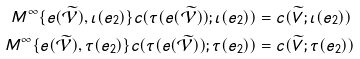<formula> <loc_0><loc_0><loc_500><loc_500>M ^ { \infty } \{ e ( \widetilde { \mathcal { V } } ) , \iota ( e _ { 2 } ) \} c ( \tau ( e ( \widetilde { \mathcal { V } } ) ) ; \iota ( e _ { 2 } ) ) & = c ( \widetilde { V } ; \iota ( e _ { 2 } ) ) \\ M ^ { \infty } \{ e ( \widetilde { \mathcal { V } } ) , \tau ( e _ { 2 } ) \} c ( \tau ( e ( \widetilde { \mathcal { V } } ) ) ; \tau ( e _ { 2 } ) ) & = c ( \widetilde { V } ; \tau ( e _ { 2 } ) )</formula> 